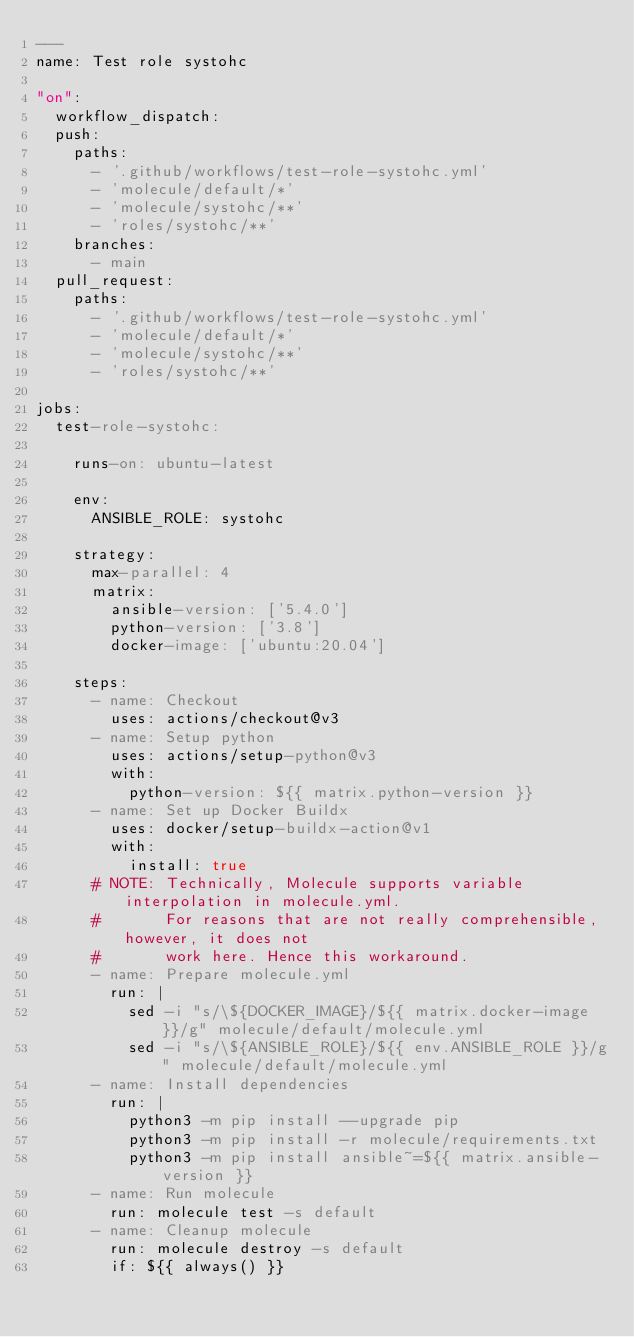Convert code to text. <code><loc_0><loc_0><loc_500><loc_500><_YAML_>---
name: Test role systohc

"on":
  workflow_dispatch:
  push:
    paths:
      - '.github/workflows/test-role-systohc.yml'
      - 'molecule/default/*'
      - 'molecule/systohc/**'
      - 'roles/systohc/**'
    branches:
      - main
  pull_request:
    paths:
      - '.github/workflows/test-role-systohc.yml'
      - 'molecule/default/*'
      - 'molecule/systohc/**'
      - 'roles/systohc/**'

jobs:
  test-role-systohc:

    runs-on: ubuntu-latest

    env:
      ANSIBLE_ROLE: systohc

    strategy:
      max-parallel: 4
      matrix:
        ansible-version: ['5.4.0']
        python-version: ['3.8']
        docker-image: ['ubuntu:20.04']

    steps:
      - name: Checkout
        uses: actions/checkout@v3
      - name: Setup python
        uses: actions/setup-python@v3
        with:
          python-version: ${{ matrix.python-version }}
      - name: Set up Docker Buildx
        uses: docker/setup-buildx-action@v1
        with:
          install: true
      # NOTE: Technically, Molecule supports variable interpolation in molecule.yml.
      #       For reasons that are not really comprehensible, however, it does not
      #       work here. Hence this workaround.
      - name: Prepare molecule.yml
        run: |
          sed -i "s/\${DOCKER_IMAGE}/${{ matrix.docker-image }}/g" molecule/default/molecule.yml
          sed -i "s/\${ANSIBLE_ROLE}/${{ env.ANSIBLE_ROLE }}/g" molecule/default/molecule.yml
      - name: Install dependencies
        run: |
          python3 -m pip install --upgrade pip
          python3 -m pip install -r molecule/requirements.txt
          python3 -m pip install ansible~=${{ matrix.ansible-version }}
      - name: Run molecule
        run: molecule test -s default
      - name: Cleanup molecule
        run: molecule destroy -s default
        if: ${{ always() }}
</code> 